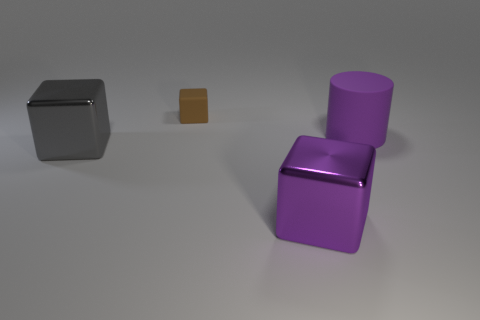Are the purple cube and the big cube that is on the left side of the small brown thing made of the same material?
Make the answer very short. Yes. What number of objects are purple matte cylinders or cyan cylinders?
Offer a very short reply. 1. Are there any matte things?
Provide a short and direct response. Yes. What shape is the matte object to the right of the large metal cube on the right side of the tiny brown thing?
Your response must be concise. Cylinder. How many objects are big things that are right of the brown block or blocks behind the large rubber cylinder?
Provide a succinct answer. 3. What material is the block that is the same size as the purple metallic object?
Your answer should be compact. Metal. What color is the tiny matte thing?
Provide a succinct answer. Brown. What is the material of the thing that is both right of the small block and to the left of the rubber cylinder?
Your answer should be very brief. Metal. Are there any large things that are on the left side of the big metal object that is behind the metal block that is to the right of the tiny thing?
Your response must be concise. No. The cube that is the same color as the big matte thing is what size?
Provide a succinct answer. Large. 